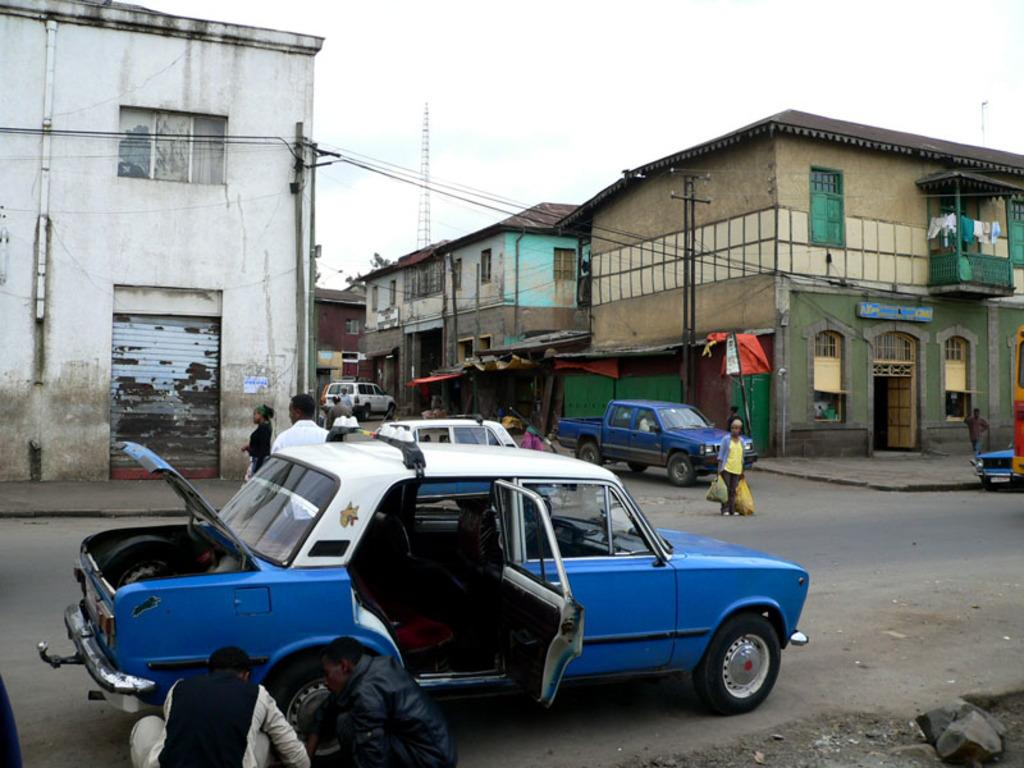What can be seen on the road in the image? There are vehicles on the road in the image. Who or what else is present in the image? There is a group of people in the image. What structures can be seen in the image? There are poles, houses, and boards in the image. Are there any wires or cables visible in the image? Yes, there are cables in the image. What is visible in the background of the image? The sky is visible in the background of the image. What is your opinion on the quartz found in the image? There is no quartz present in the image, so it is not possible to provide an opinion on it. 